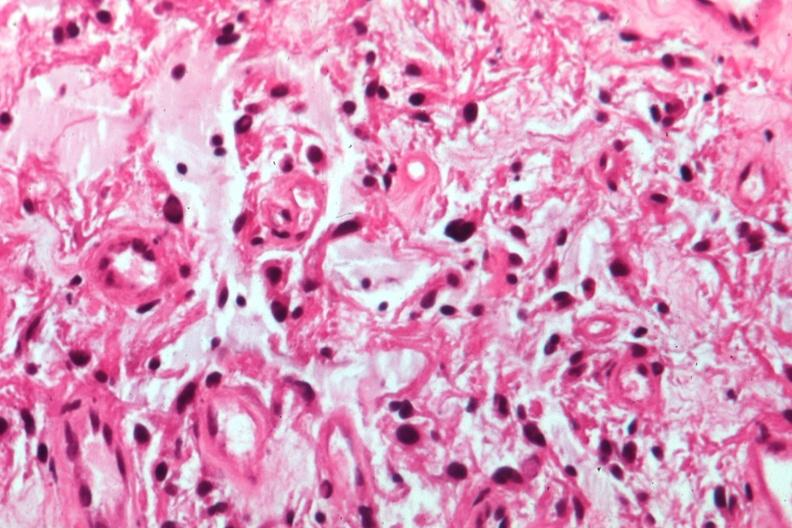does immunostain for growth hormone show glioma?
Answer the question using a single word or phrase. No 